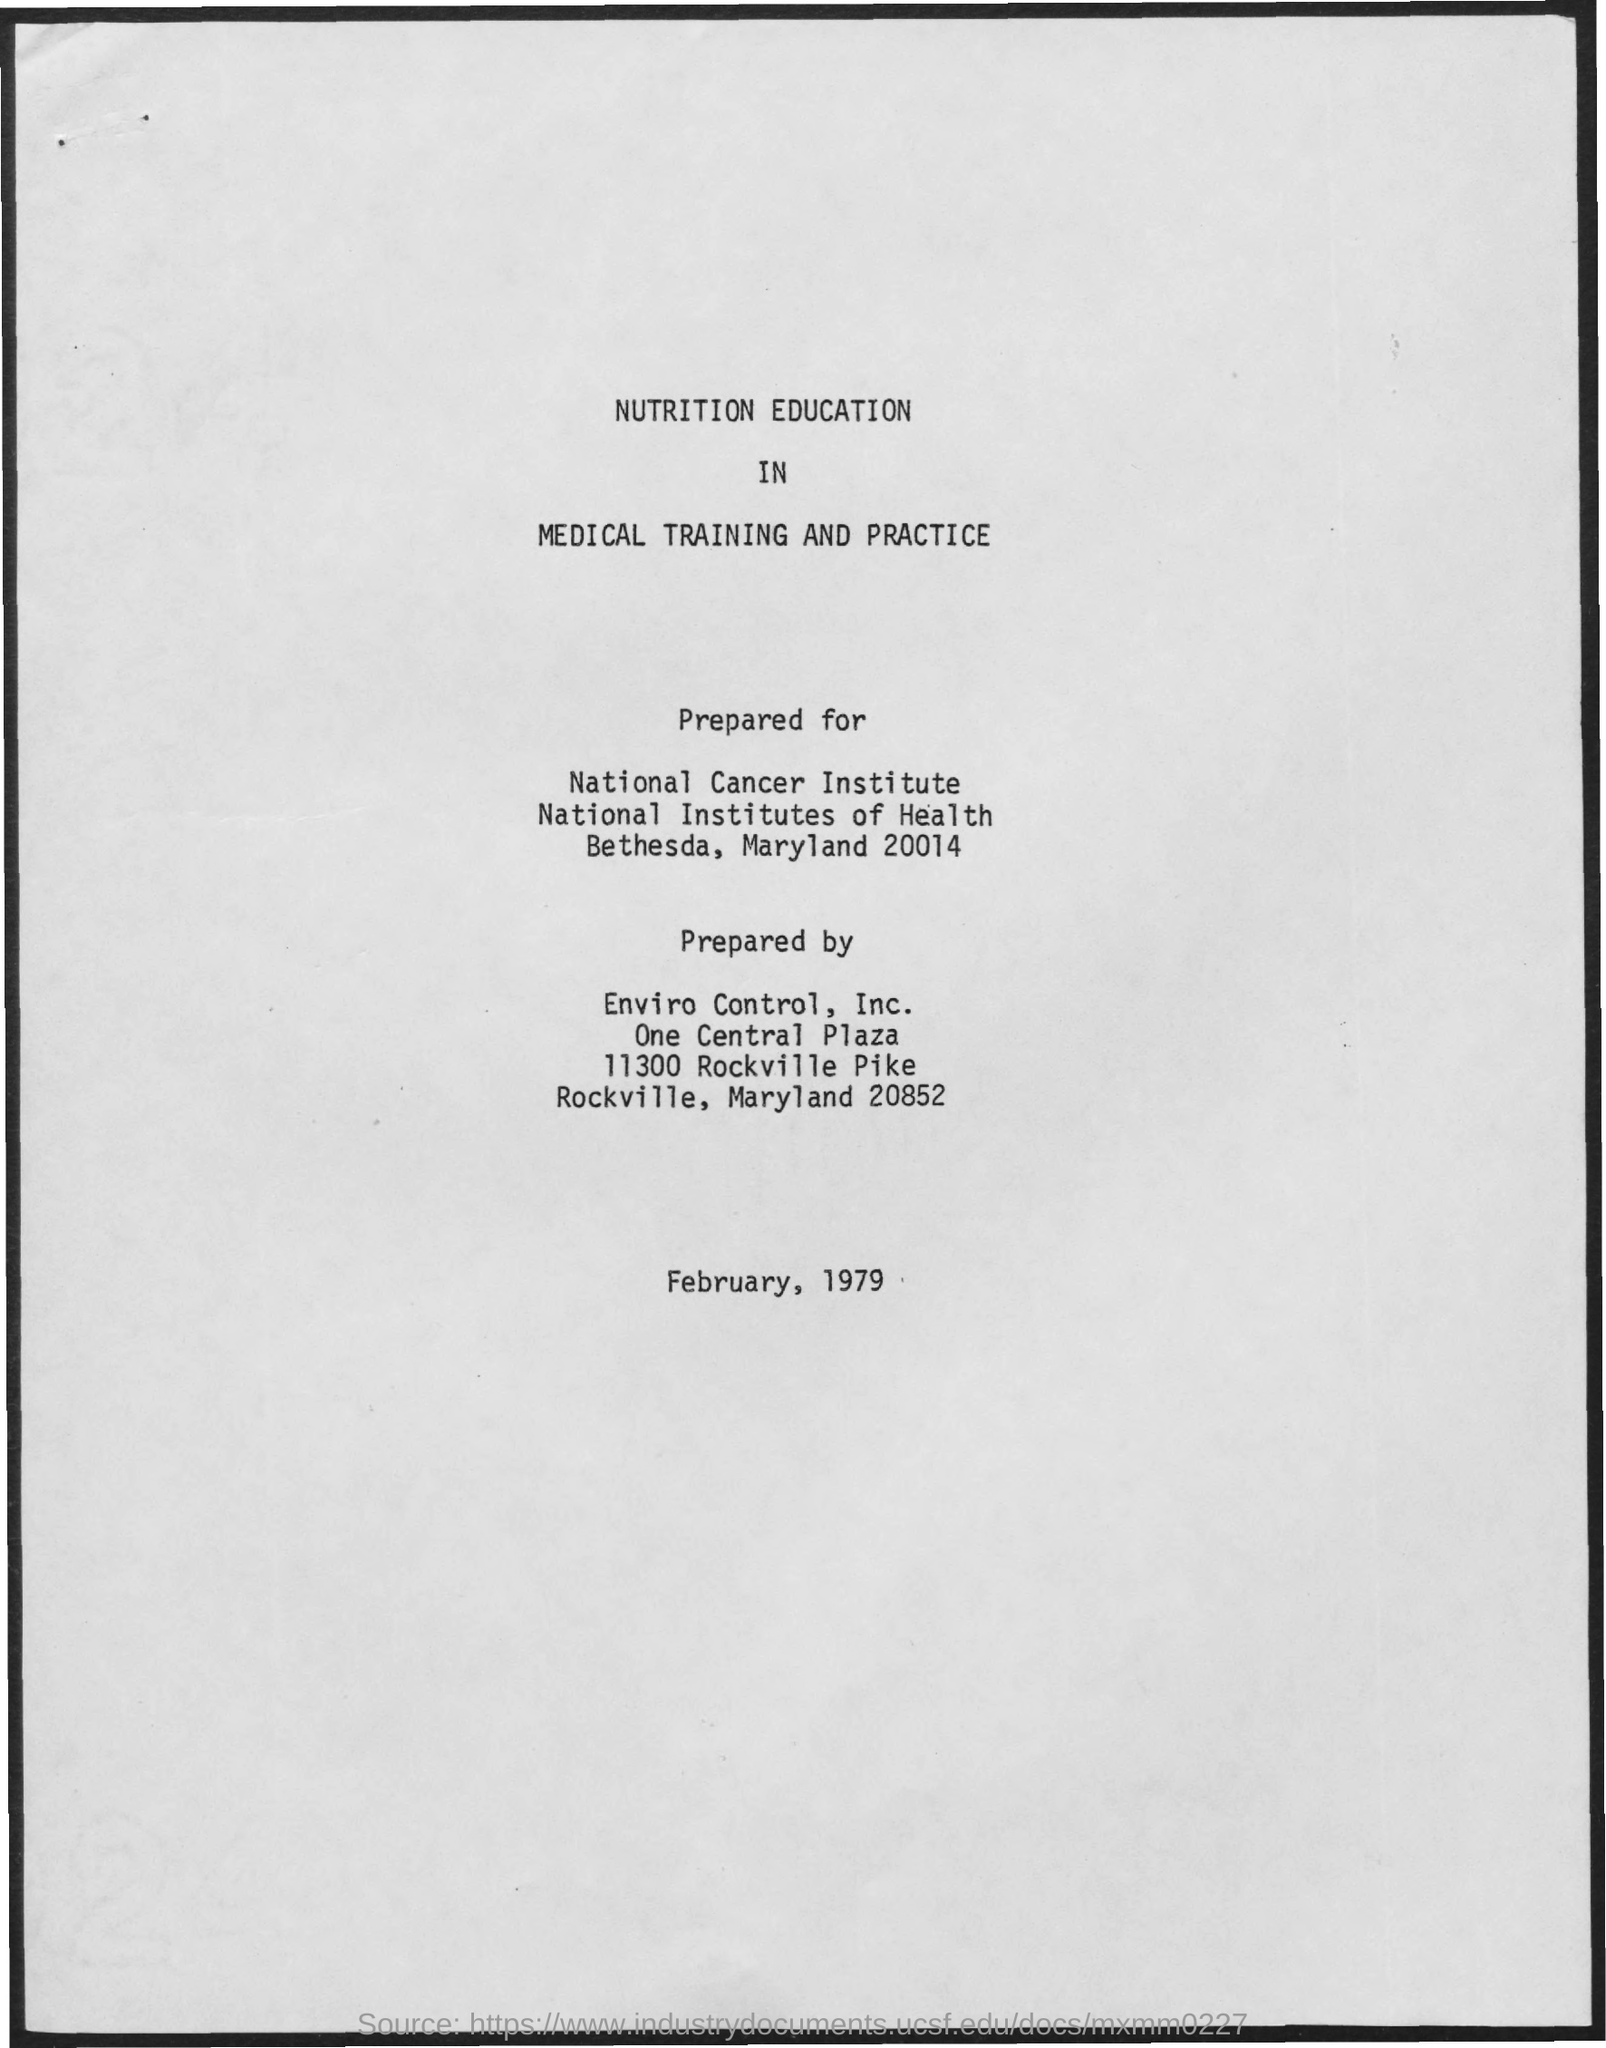Highlight a few significant elements in this photo. The date on the document is February 1979. 